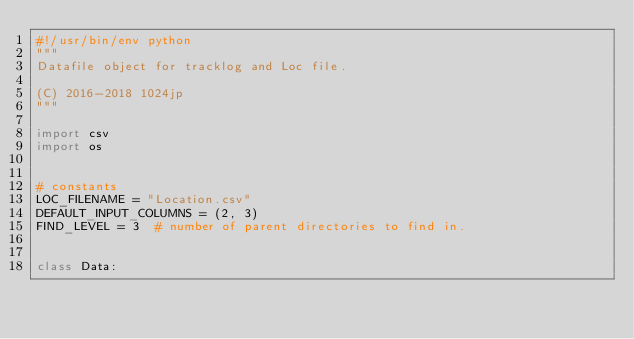<code> <loc_0><loc_0><loc_500><loc_500><_Python_>#!/usr/bin/env python
"""
Datafile object for tracklog and Loc file.

(C) 2016-2018 1024jp
"""

import csv
import os


# constants
LOC_FILENAME = "Location.csv"
DEFAULT_INPUT_COLUMNS = (2, 3)
FIND_LEVEL = 3  # number of parent directories to find in.


class Data:</code> 